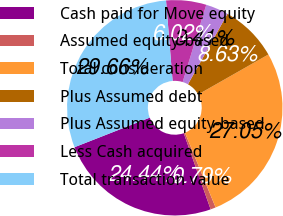<chart> <loc_0><loc_0><loc_500><loc_500><pie_chart><fcel>Cash paid for Move equity<fcel>Assumed equity-based<fcel>Total consideration<fcel>Plus Assumed debt<fcel>Plus Assumed equity-based<fcel>Less Cash acquired<fcel>Total transaction value<nl><fcel>24.44%<fcel>0.79%<fcel>27.05%<fcel>8.63%<fcel>3.41%<fcel>6.02%<fcel>29.66%<nl></chart> 